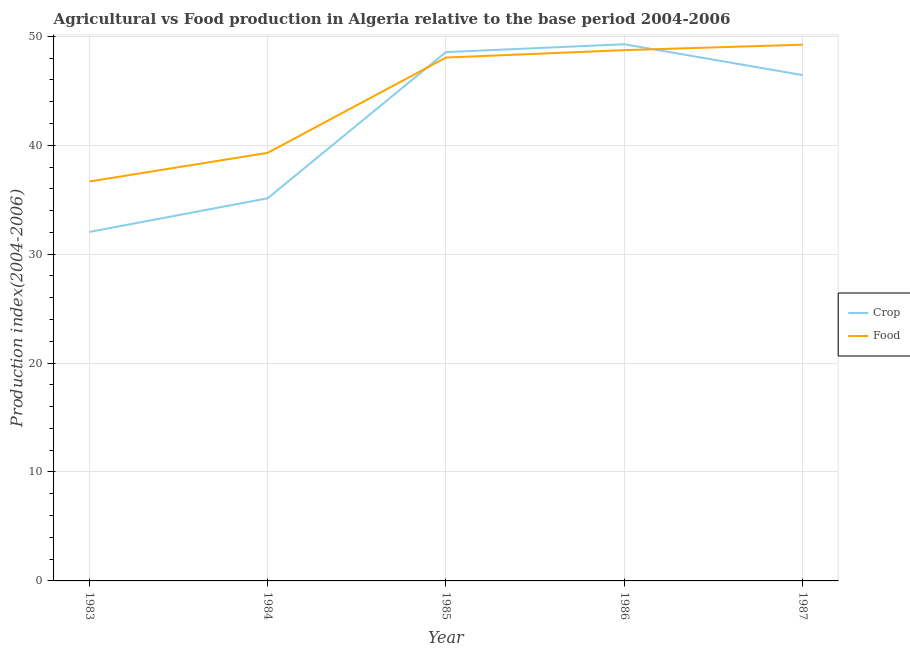How many different coloured lines are there?
Offer a terse response. 2. Is the number of lines equal to the number of legend labels?
Provide a succinct answer. Yes. What is the crop production index in 1984?
Offer a terse response. 35.13. Across all years, what is the maximum food production index?
Offer a very short reply. 49.23. Across all years, what is the minimum food production index?
Offer a terse response. 36.67. In which year was the crop production index maximum?
Give a very brief answer. 1986. In which year was the crop production index minimum?
Make the answer very short. 1983. What is the total food production index in the graph?
Make the answer very short. 221.98. What is the difference between the crop production index in 1985 and that in 1987?
Give a very brief answer. 2.11. What is the difference between the crop production index in 1983 and the food production index in 1984?
Give a very brief answer. -7.26. What is the average crop production index per year?
Your answer should be compact. 42.29. In the year 1987, what is the difference between the food production index and crop production index?
Your answer should be compact. 2.79. In how many years, is the crop production index greater than 20?
Provide a succinct answer. 5. What is the ratio of the food production index in 1984 to that in 1986?
Provide a succinct answer. 0.81. Is the food production index in 1984 less than that in 1987?
Your answer should be very brief. Yes. What is the difference between the highest and the second highest crop production index?
Your answer should be very brief. 0.72. What is the difference between the highest and the lowest food production index?
Provide a short and direct response. 12.56. In how many years, is the crop production index greater than the average crop production index taken over all years?
Your response must be concise. 3. Does the crop production index monotonically increase over the years?
Your response must be concise. No. Is the food production index strictly less than the crop production index over the years?
Offer a very short reply. No. How many lines are there?
Offer a very short reply. 2. Are the values on the major ticks of Y-axis written in scientific E-notation?
Your answer should be compact. No. Does the graph contain any zero values?
Provide a short and direct response. No. Where does the legend appear in the graph?
Your response must be concise. Center right. How many legend labels are there?
Ensure brevity in your answer.  2. How are the legend labels stacked?
Offer a terse response. Vertical. What is the title of the graph?
Your answer should be compact. Agricultural vs Food production in Algeria relative to the base period 2004-2006. What is the label or title of the X-axis?
Offer a very short reply. Year. What is the label or title of the Y-axis?
Provide a short and direct response. Production index(2004-2006). What is the Production index(2004-2006) in Crop in 1983?
Give a very brief answer. 32.04. What is the Production index(2004-2006) in Food in 1983?
Provide a short and direct response. 36.67. What is the Production index(2004-2006) of Crop in 1984?
Offer a very short reply. 35.13. What is the Production index(2004-2006) of Food in 1984?
Provide a short and direct response. 39.3. What is the Production index(2004-2006) in Crop in 1985?
Your answer should be very brief. 48.55. What is the Production index(2004-2006) of Food in 1985?
Your answer should be compact. 48.05. What is the Production index(2004-2006) of Crop in 1986?
Give a very brief answer. 49.27. What is the Production index(2004-2006) in Food in 1986?
Your answer should be very brief. 48.73. What is the Production index(2004-2006) of Crop in 1987?
Keep it short and to the point. 46.44. What is the Production index(2004-2006) of Food in 1987?
Your answer should be compact. 49.23. Across all years, what is the maximum Production index(2004-2006) in Crop?
Your response must be concise. 49.27. Across all years, what is the maximum Production index(2004-2006) in Food?
Make the answer very short. 49.23. Across all years, what is the minimum Production index(2004-2006) of Crop?
Offer a very short reply. 32.04. Across all years, what is the minimum Production index(2004-2006) in Food?
Your response must be concise. 36.67. What is the total Production index(2004-2006) in Crop in the graph?
Offer a terse response. 211.43. What is the total Production index(2004-2006) of Food in the graph?
Make the answer very short. 221.98. What is the difference between the Production index(2004-2006) in Crop in 1983 and that in 1984?
Your response must be concise. -3.09. What is the difference between the Production index(2004-2006) of Food in 1983 and that in 1984?
Offer a very short reply. -2.63. What is the difference between the Production index(2004-2006) in Crop in 1983 and that in 1985?
Provide a short and direct response. -16.51. What is the difference between the Production index(2004-2006) of Food in 1983 and that in 1985?
Provide a short and direct response. -11.38. What is the difference between the Production index(2004-2006) in Crop in 1983 and that in 1986?
Keep it short and to the point. -17.23. What is the difference between the Production index(2004-2006) of Food in 1983 and that in 1986?
Your response must be concise. -12.06. What is the difference between the Production index(2004-2006) in Crop in 1983 and that in 1987?
Make the answer very short. -14.4. What is the difference between the Production index(2004-2006) of Food in 1983 and that in 1987?
Keep it short and to the point. -12.56. What is the difference between the Production index(2004-2006) in Crop in 1984 and that in 1985?
Offer a terse response. -13.42. What is the difference between the Production index(2004-2006) in Food in 1984 and that in 1985?
Ensure brevity in your answer.  -8.75. What is the difference between the Production index(2004-2006) in Crop in 1984 and that in 1986?
Offer a very short reply. -14.14. What is the difference between the Production index(2004-2006) of Food in 1984 and that in 1986?
Offer a terse response. -9.43. What is the difference between the Production index(2004-2006) of Crop in 1984 and that in 1987?
Offer a terse response. -11.31. What is the difference between the Production index(2004-2006) in Food in 1984 and that in 1987?
Your answer should be compact. -9.93. What is the difference between the Production index(2004-2006) in Crop in 1985 and that in 1986?
Your answer should be very brief. -0.72. What is the difference between the Production index(2004-2006) in Food in 1985 and that in 1986?
Provide a succinct answer. -0.68. What is the difference between the Production index(2004-2006) of Crop in 1985 and that in 1987?
Provide a short and direct response. 2.11. What is the difference between the Production index(2004-2006) of Food in 1985 and that in 1987?
Your answer should be very brief. -1.18. What is the difference between the Production index(2004-2006) in Crop in 1986 and that in 1987?
Offer a terse response. 2.83. What is the difference between the Production index(2004-2006) in Food in 1986 and that in 1987?
Give a very brief answer. -0.5. What is the difference between the Production index(2004-2006) of Crop in 1983 and the Production index(2004-2006) of Food in 1984?
Your answer should be very brief. -7.26. What is the difference between the Production index(2004-2006) of Crop in 1983 and the Production index(2004-2006) of Food in 1985?
Ensure brevity in your answer.  -16.01. What is the difference between the Production index(2004-2006) of Crop in 1983 and the Production index(2004-2006) of Food in 1986?
Provide a succinct answer. -16.69. What is the difference between the Production index(2004-2006) of Crop in 1983 and the Production index(2004-2006) of Food in 1987?
Offer a very short reply. -17.19. What is the difference between the Production index(2004-2006) in Crop in 1984 and the Production index(2004-2006) in Food in 1985?
Provide a succinct answer. -12.92. What is the difference between the Production index(2004-2006) in Crop in 1984 and the Production index(2004-2006) in Food in 1987?
Give a very brief answer. -14.1. What is the difference between the Production index(2004-2006) in Crop in 1985 and the Production index(2004-2006) in Food in 1986?
Your response must be concise. -0.18. What is the difference between the Production index(2004-2006) of Crop in 1985 and the Production index(2004-2006) of Food in 1987?
Ensure brevity in your answer.  -0.68. What is the average Production index(2004-2006) of Crop per year?
Ensure brevity in your answer.  42.29. What is the average Production index(2004-2006) in Food per year?
Provide a short and direct response. 44.4. In the year 1983, what is the difference between the Production index(2004-2006) of Crop and Production index(2004-2006) of Food?
Provide a short and direct response. -4.63. In the year 1984, what is the difference between the Production index(2004-2006) of Crop and Production index(2004-2006) of Food?
Provide a short and direct response. -4.17. In the year 1985, what is the difference between the Production index(2004-2006) in Crop and Production index(2004-2006) in Food?
Give a very brief answer. 0.5. In the year 1986, what is the difference between the Production index(2004-2006) in Crop and Production index(2004-2006) in Food?
Offer a terse response. 0.54. In the year 1987, what is the difference between the Production index(2004-2006) of Crop and Production index(2004-2006) of Food?
Your response must be concise. -2.79. What is the ratio of the Production index(2004-2006) of Crop in 1983 to that in 1984?
Your response must be concise. 0.91. What is the ratio of the Production index(2004-2006) of Food in 1983 to that in 1984?
Your answer should be compact. 0.93. What is the ratio of the Production index(2004-2006) in Crop in 1983 to that in 1985?
Your answer should be very brief. 0.66. What is the ratio of the Production index(2004-2006) of Food in 1983 to that in 1985?
Provide a short and direct response. 0.76. What is the ratio of the Production index(2004-2006) in Crop in 1983 to that in 1986?
Ensure brevity in your answer.  0.65. What is the ratio of the Production index(2004-2006) of Food in 1983 to that in 1986?
Ensure brevity in your answer.  0.75. What is the ratio of the Production index(2004-2006) of Crop in 1983 to that in 1987?
Keep it short and to the point. 0.69. What is the ratio of the Production index(2004-2006) in Food in 1983 to that in 1987?
Provide a short and direct response. 0.74. What is the ratio of the Production index(2004-2006) in Crop in 1984 to that in 1985?
Ensure brevity in your answer.  0.72. What is the ratio of the Production index(2004-2006) in Food in 1984 to that in 1985?
Provide a short and direct response. 0.82. What is the ratio of the Production index(2004-2006) of Crop in 1984 to that in 1986?
Your answer should be very brief. 0.71. What is the ratio of the Production index(2004-2006) in Food in 1984 to that in 1986?
Offer a very short reply. 0.81. What is the ratio of the Production index(2004-2006) of Crop in 1984 to that in 1987?
Your answer should be very brief. 0.76. What is the ratio of the Production index(2004-2006) of Food in 1984 to that in 1987?
Offer a very short reply. 0.8. What is the ratio of the Production index(2004-2006) of Crop in 1985 to that in 1986?
Your answer should be compact. 0.99. What is the ratio of the Production index(2004-2006) of Food in 1985 to that in 1986?
Your answer should be compact. 0.99. What is the ratio of the Production index(2004-2006) in Crop in 1985 to that in 1987?
Ensure brevity in your answer.  1.05. What is the ratio of the Production index(2004-2006) in Crop in 1986 to that in 1987?
Your answer should be compact. 1.06. What is the difference between the highest and the second highest Production index(2004-2006) of Crop?
Ensure brevity in your answer.  0.72. What is the difference between the highest and the lowest Production index(2004-2006) in Crop?
Make the answer very short. 17.23. What is the difference between the highest and the lowest Production index(2004-2006) of Food?
Offer a terse response. 12.56. 